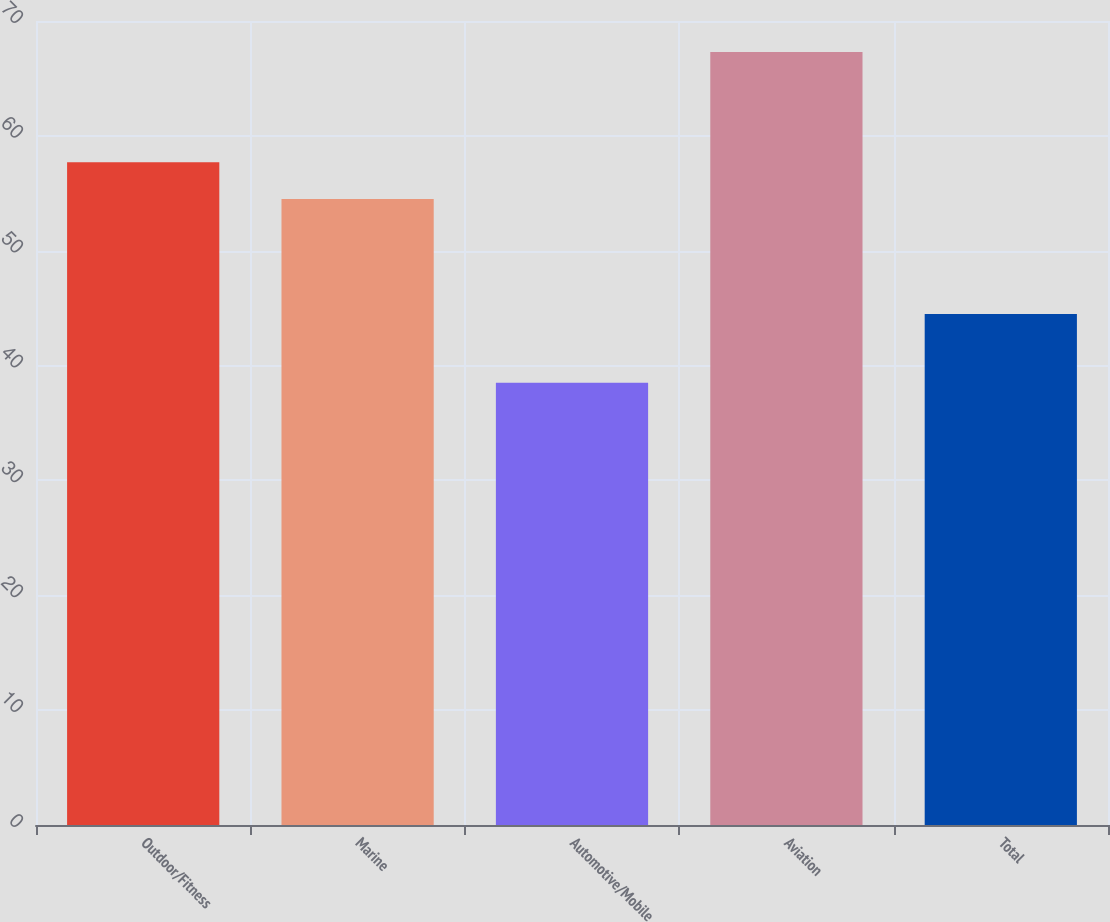Convert chart to OTSL. <chart><loc_0><loc_0><loc_500><loc_500><bar_chart><fcel>Outdoor/Fitness<fcel>Marine<fcel>Automotive/Mobile<fcel>Aviation<fcel>Total<nl><fcel>57.7<fcel>54.5<fcel>38.5<fcel>67.3<fcel>44.5<nl></chart> 